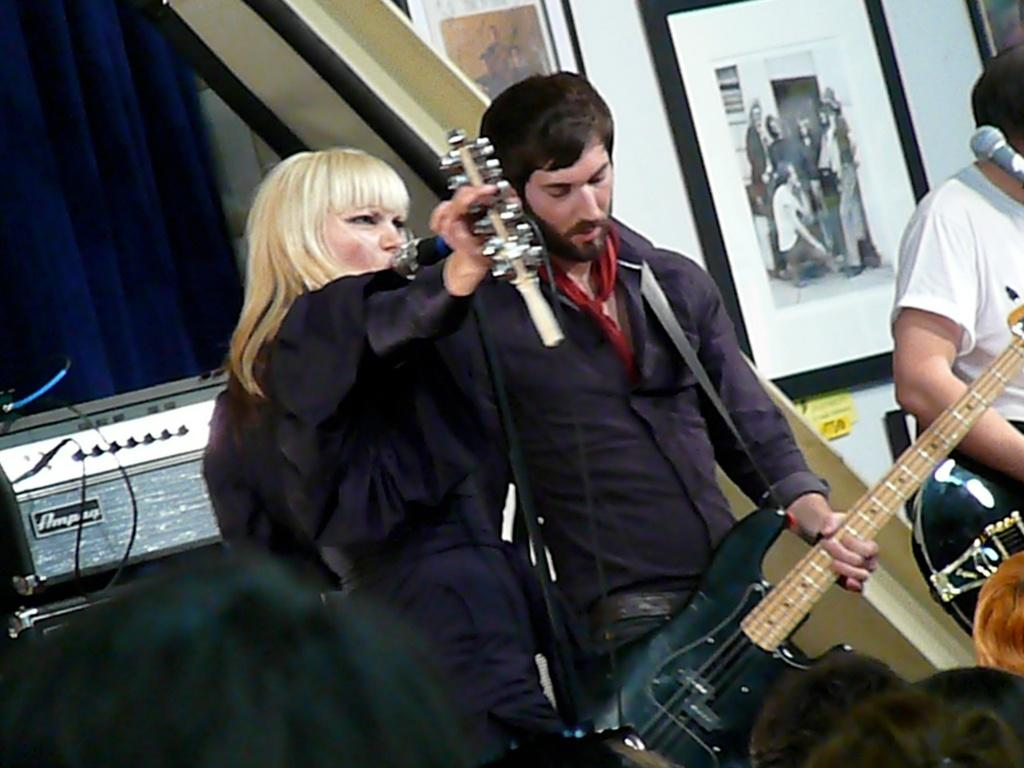How many people are in the image? There is a group of people in the image. What are two of the men doing in the image? Two men are holding guitars in the image. What is the woman doing in the image? A woman is singing on a microphone in the image. What can be seen in the background of the image? There is a curtain and frames in the background of the image. What type of butter is being used by the musicians in the image? There is no butter present in the image; it features a group of people playing music and singing. How many chairs are visible in the image? There is no mention of chairs in the image; it focuses on the group of people and their musical instruments and microphone. 